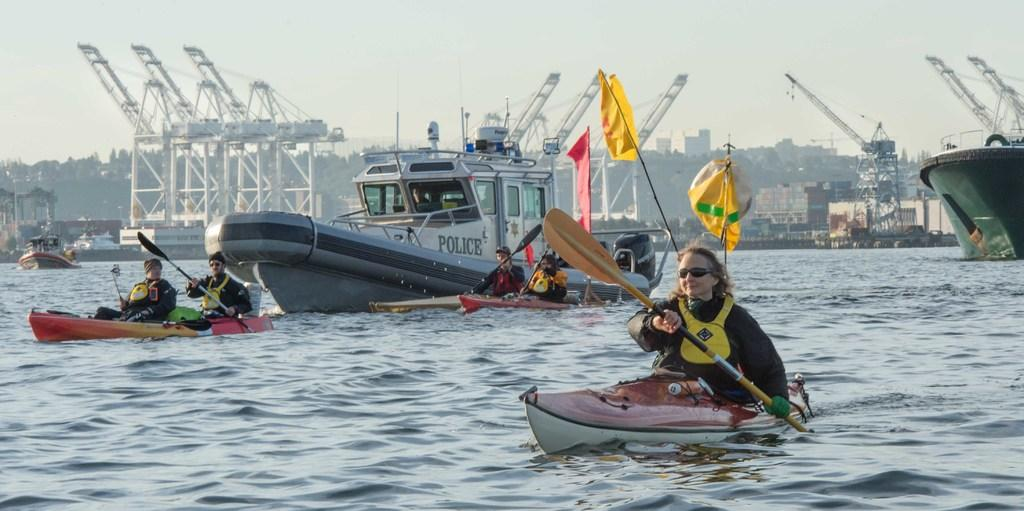What is the main activity taking place in the foreground of the image? There is a woman surfing in the foreground of the image. What can be seen in the middle of the image? There is a ship in the middle of the image. What is visible in the background of the image? The sky is visible in the background of the image. Where is the baby holding the leaf in the image? There is no baby or leaf present in the image. What type of cheese is visible on the surfboard in the image? There is no cheese present in the image; it features a woman surfing and a ship in the middle. 